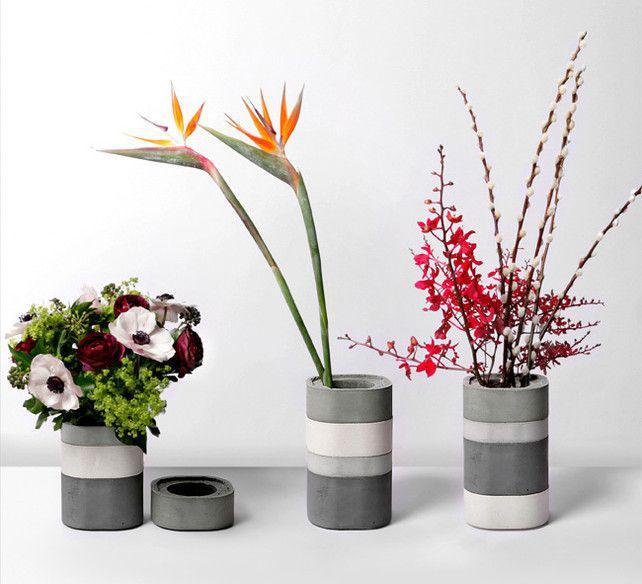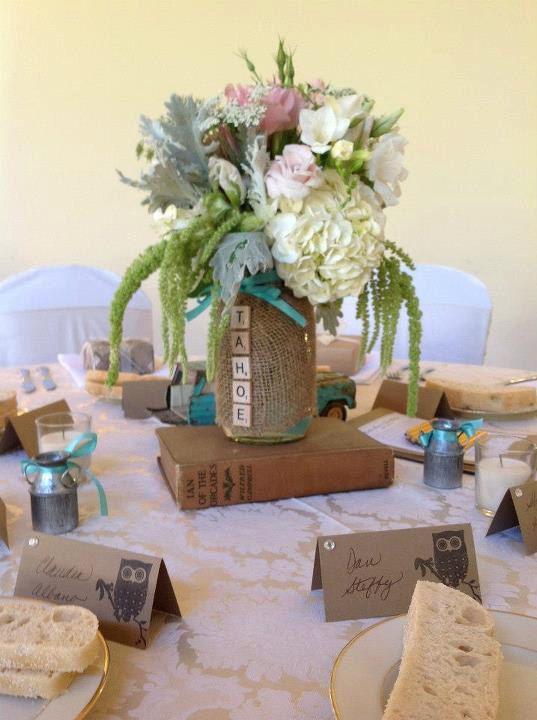The first image is the image on the left, the second image is the image on the right. Analyze the images presented: Is the assertion "One photo shows at least three exclusively white opaque decorative containers that are not holding flowers." valid? Answer yes or no. No. The first image is the image on the left, the second image is the image on the right. Considering the images on both sides, is "Both images contain flowering plants in vertical containers." valid? Answer yes or no. Yes. 